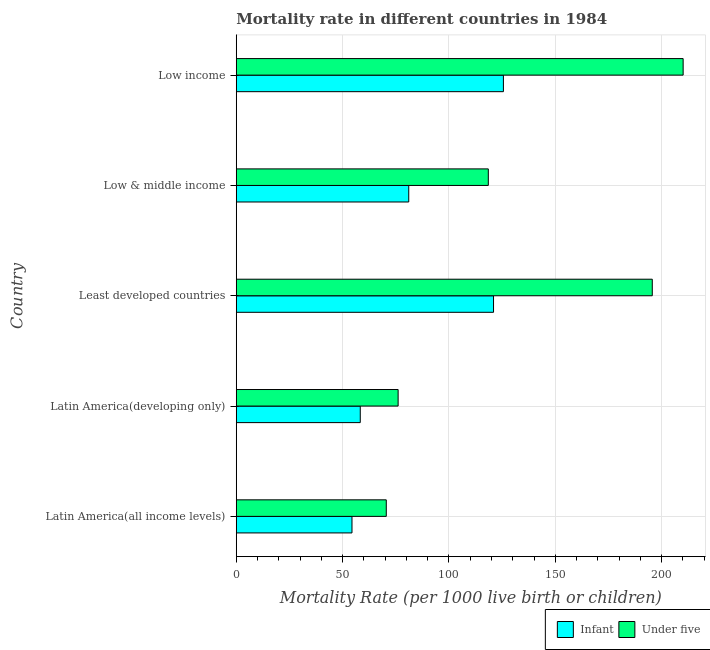How many groups of bars are there?
Give a very brief answer. 5. Are the number of bars on each tick of the Y-axis equal?
Your answer should be compact. Yes. What is the label of the 5th group of bars from the top?
Offer a very short reply. Latin America(all income levels). What is the under-5 mortality rate in Least developed countries?
Provide a succinct answer. 195.59. Across all countries, what is the maximum infant mortality rate?
Make the answer very short. 125.6. Across all countries, what is the minimum infant mortality rate?
Ensure brevity in your answer.  54.41. In which country was the infant mortality rate minimum?
Give a very brief answer. Latin America(all income levels). What is the total infant mortality rate in the graph?
Provide a short and direct response. 440.36. What is the difference between the under-5 mortality rate in Latin America(developing only) and that in Low & middle income?
Provide a succinct answer. -42.4. What is the difference between the infant mortality rate in Least developed countries and the under-5 mortality rate in Latin America(all income levels)?
Your answer should be very brief. 50.42. What is the average under-5 mortality rate per country?
Your answer should be very brief. 134.16. What is the difference between the infant mortality rate and under-5 mortality rate in Low income?
Make the answer very short. -84.5. In how many countries, is the under-5 mortality rate greater than 80 ?
Your answer should be very brief. 3. What is the difference between the highest and the second highest infant mortality rate?
Offer a terse response. 4.65. What is the difference between the highest and the lowest under-5 mortality rate?
Provide a succinct answer. 139.57. In how many countries, is the infant mortality rate greater than the average infant mortality rate taken over all countries?
Provide a short and direct response. 2. Is the sum of the infant mortality rate in Latin America(all income levels) and Least developed countries greater than the maximum under-5 mortality rate across all countries?
Give a very brief answer. No. What does the 2nd bar from the top in Latin America(all income levels) represents?
Provide a succinct answer. Infant. What does the 1st bar from the bottom in Low income represents?
Provide a succinct answer. Infant. How many bars are there?
Give a very brief answer. 10. How many countries are there in the graph?
Make the answer very short. 5. What is the difference between two consecutive major ticks on the X-axis?
Your response must be concise. 50. Are the values on the major ticks of X-axis written in scientific E-notation?
Your answer should be compact. No. Does the graph contain grids?
Provide a succinct answer. Yes. Where does the legend appear in the graph?
Give a very brief answer. Bottom right. How many legend labels are there?
Your response must be concise. 2. What is the title of the graph?
Offer a very short reply. Mortality rate in different countries in 1984. What is the label or title of the X-axis?
Your answer should be compact. Mortality Rate (per 1000 live birth or children). What is the label or title of the Y-axis?
Offer a terse response. Country. What is the Mortality Rate (per 1000 live birth or children) of Infant in Latin America(all income levels)?
Offer a very short reply. 54.41. What is the Mortality Rate (per 1000 live birth or children) in Under five in Latin America(all income levels)?
Give a very brief answer. 70.53. What is the Mortality Rate (per 1000 live birth or children) of Infant in Latin America(developing only)?
Give a very brief answer. 58.3. What is the Mortality Rate (per 1000 live birth or children) in Under five in Latin America(developing only)?
Keep it short and to the point. 76.1. What is the Mortality Rate (per 1000 live birth or children) of Infant in Least developed countries?
Keep it short and to the point. 120.95. What is the Mortality Rate (per 1000 live birth or children) of Under five in Least developed countries?
Make the answer very short. 195.59. What is the Mortality Rate (per 1000 live birth or children) in Infant in Low & middle income?
Your answer should be very brief. 81.1. What is the Mortality Rate (per 1000 live birth or children) of Under five in Low & middle income?
Make the answer very short. 118.5. What is the Mortality Rate (per 1000 live birth or children) in Infant in Low income?
Your answer should be compact. 125.6. What is the Mortality Rate (per 1000 live birth or children) in Under five in Low income?
Ensure brevity in your answer.  210.1. Across all countries, what is the maximum Mortality Rate (per 1000 live birth or children) in Infant?
Your response must be concise. 125.6. Across all countries, what is the maximum Mortality Rate (per 1000 live birth or children) in Under five?
Provide a short and direct response. 210.1. Across all countries, what is the minimum Mortality Rate (per 1000 live birth or children) of Infant?
Your answer should be compact. 54.41. Across all countries, what is the minimum Mortality Rate (per 1000 live birth or children) of Under five?
Ensure brevity in your answer.  70.53. What is the total Mortality Rate (per 1000 live birth or children) of Infant in the graph?
Offer a terse response. 440.36. What is the total Mortality Rate (per 1000 live birth or children) in Under five in the graph?
Your answer should be very brief. 670.82. What is the difference between the Mortality Rate (per 1000 live birth or children) of Infant in Latin America(all income levels) and that in Latin America(developing only)?
Make the answer very short. -3.89. What is the difference between the Mortality Rate (per 1000 live birth or children) of Under five in Latin America(all income levels) and that in Latin America(developing only)?
Your answer should be very brief. -5.57. What is the difference between the Mortality Rate (per 1000 live birth or children) of Infant in Latin America(all income levels) and that in Least developed countries?
Your answer should be very brief. -66.54. What is the difference between the Mortality Rate (per 1000 live birth or children) of Under five in Latin America(all income levels) and that in Least developed countries?
Make the answer very short. -125.06. What is the difference between the Mortality Rate (per 1000 live birth or children) of Infant in Latin America(all income levels) and that in Low & middle income?
Provide a short and direct response. -26.69. What is the difference between the Mortality Rate (per 1000 live birth or children) in Under five in Latin America(all income levels) and that in Low & middle income?
Keep it short and to the point. -47.97. What is the difference between the Mortality Rate (per 1000 live birth or children) in Infant in Latin America(all income levels) and that in Low income?
Provide a succinct answer. -71.19. What is the difference between the Mortality Rate (per 1000 live birth or children) of Under five in Latin America(all income levels) and that in Low income?
Your response must be concise. -139.57. What is the difference between the Mortality Rate (per 1000 live birth or children) of Infant in Latin America(developing only) and that in Least developed countries?
Give a very brief answer. -62.65. What is the difference between the Mortality Rate (per 1000 live birth or children) of Under five in Latin America(developing only) and that in Least developed countries?
Keep it short and to the point. -119.49. What is the difference between the Mortality Rate (per 1000 live birth or children) in Infant in Latin America(developing only) and that in Low & middle income?
Offer a very short reply. -22.8. What is the difference between the Mortality Rate (per 1000 live birth or children) in Under five in Latin America(developing only) and that in Low & middle income?
Provide a succinct answer. -42.4. What is the difference between the Mortality Rate (per 1000 live birth or children) of Infant in Latin America(developing only) and that in Low income?
Make the answer very short. -67.3. What is the difference between the Mortality Rate (per 1000 live birth or children) of Under five in Latin America(developing only) and that in Low income?
Ensure brevity in your answer.  -134. What is the difference between the Mortality Rate (per 1000 live birth or children) of Infant in Least developed countries and that in Low & middle income?
Your answer should be very brief. 39.85. What is the difference between the Mortality Rate (per 1000 live birth or children) in Under five in Least developed countries and that in Low & middle income?
Provide a short and direct response. 77.09. What is the difference between the Mortality Rate (per 1000 live birth or children) of Infant in Least developed countries and that in Low income?
Provide a succinct answer. -4.65. What is the difference between the Mortality Rate (per 1000 live birth or children) of Under five in Least developed countries and that in Low income?
Provide a short and direct response. -14.51. What is the difference between the Mortality Rate (per 1000 live birth or children) in Infant in Low & middle income and that in Low income?
Your answer should be compact. -44.5. What is the difference between the Mortality Rate (per 1000 live birth or children) of Under five in Low & middle income and that in Low income?
Your answer should be very brief. -91.6. What is the difference between the Mortality Rate (per 1000 live birth or children) of Infant in Latin America(all income levels) and the Mortality Rate (per 1000 live birth or children) of Under five in Latin America(developing only)?
Provide a succinct answer. -21.69. What is the difference between the Mortality Rate (per 1000 live birth or children) in Infant in Latin America(all income levels) and the Mortality Rate (per 1000 live birth or children) in Under five in Least developed countries?
Keep it short and to the point. -141.18. What is the difference between the Mortality Rate (per 1000 live birth or children) of Infant in Latin America(all income levels) and the Mortality Rate (per 1000 live birth or children) of Under five in Low & middle income?
Provide a succinct answer. -64.09. What is the difference between the Mortality Rate (per 1000 live birth or children) of Infant in Latin America(all income levels) and the Mortality Rate (per 1000 live birth or children) of Under five in Low income?
Your answer should be very brief. -155.69. What is the difference between the Mortality Rate (per 1000 live birth or children) of Infant in Latin America(developing only) and the Mortality Rate (per 1000 live birth or children) of Under five in Least developed countries?
Your answer should be very brief. -137.29. What is the difference between the Mortality Rate (per 1000 live birth or children) in Infant in Latin America(developing only) and the Mortality Rate (per 1000 live birth or children) in Under five in Low & middle income?
Offer a very short reply. -60.2. What is the difference between the Mortality Rate (per 1000 live birth or children) of Infant in Latin America(developing only) and the Mortality Rate (per 1000 live birth or children) of Under five in Low income?
Provide a succinct answer. -151.8. What is the difference between the Mortality Rate (per 1000 live birth or children) of Infant in Least developed countries and the Mortality Rate (per 1000 live birth or children) of Under five in Low & middle income?
Offer a terse response. 2.45. What is the difference between the Mortality Rate (per 1000 live birth or children) of Infant in Least developed countries and the Mortality Rate (per 1000 live birth or children) of Under five in Low income?
Ensure brevity in your answer.  -89.15. What is the difference between the Mortality Rate (per 1000 live birth or children) of Infant in Low & middle income and the Mortality Rate (per 1000 live birth or children) of Under five in Low income?
Offer a very short reply. -129. What is the average Mortality Rate (per 1000 live birth or children) in Infant per country?
Ensure brevity in your answer.  88.07. What is the average Mortality Rate (per 1000 live birth or children) in Under five per country?
Keep it short and to the point. 134.16. What is the difference between the Mortality Rate (per 1000 live birth or children) of Infant and Mortality Rate (per 1000 live birth or children) of Under five in Latin America(all income levels)?
Your answer should be compact. -16.12. What is the difference between the Mortality Rate (per 1000 live birth or children) in Infant and Mortality Rate (per 1000 live birth or children) in Under five in Latin America(developing only)?
Provide a short and direct response. -17.8. What is the difference between the Mortality Rate (per 1000 live birth or children) in Infant and Mortality Rate (per 1000 live birth or children) in Under five in Least developed countries?
Provide a short and direct response. -74.64. What is the difference between the Mortality Rate (per 1000 live birth or children) in Infant and Mortality Rate (per 1000 live birth or children) in Under five in Low & middle income?
Offer a terse response. -37.4. What is the difference between the Mortality Rate (per 1000 live birth or children) in Infant and Mortality Rate (per 1000 live birth or children) in Under five in Low income?
Provide a short and direct response. -84.5. What is the ratio of the Mortality Rate (per 1000 live birth or children) of Infant in Latin America(all income levels) to that in Latin America(developing only)?
Provide a succinct answer. 0.93. What is the ratio of the Mortality Rate (per 1000 live birth or children) of Under five in Latin America(all income levels) to that in Latin America(developing only)?
Your response must be concise. 0.93. What is the ratio of the Mortality Rate (per 1000 live birth or children) in Infant in Latin America(all income levels) to that in Least developed countries?
Make the answer very short. 0.45. What is the ratio of the Mortality Rate (per 1000 live birth or children) in Under five in Latin America(all income levels) to that in Least developed countries?
Provide a succinct answer. 0.36. What is the ratio of the Mortality Rate (per 1000 live birth or children) in Infant in Latin America(all income levels) to that in Low & middle income?
Offer a terse response. 0.67. What is the ratio of the Mortality Rate (per 1000 live birth or children) of Under five in Latin America(all income levels) to that in Low & middle income?
Make the answer very short. 0.6. What is the ratio of the Mortality Rate (per 1000 live birth or children) of Infant in Latin America(all income levels) to that in Low income?
Keep it short and to the point. 0.43. What is the ratio of the Mortality Rate (per 1000 live birth or children) of Under five in Latin America(all income levels) to that in Low income?
Give a very brief answer. 0.34. What is the ratio of the Mortality Rate (per 1000 live birth or children) in Infant in Latin America(developing only) to that in Least developed countries?
Your response must be concise. 0.48. What is the ratio of the Mortality Rate (per 1000 live birth or children) of Under five in Latin America(developing only) to that in Least developed countries?
Provide a succinct answer. 0.39. What is the ratio of the Mortality Rate (per 1000 live birth or children) of Infant in Latin America(developing only) to that in Low & middle income?
Your response must be concise. 0.72. What is the ratio of the Mortality Rate (per 1000 live birth or children) in Under five in Latin America(developing only) to that in Low & middle income?
Provide a succinct answer. 0.64. What is the ratio of the Mortality Rate (per 1000 live birth or children) in Infant in Latin America(developing only) to that in Low income?
Provide a succinct answer. 0.46. What is the ratio of the Mortality Rate (per 1000 live birth or children) of Under five in Latin America(developing only) to that in Low income?
Give a very brief answer. 0.36. What is the ratio of the Mortality Rate (per 1000 live birth or children) in Infant in Least developed countries to that in Low & middle income?
Your response must be concise. 1.49. What is the ratio of the Mortality Rate (per 1000 live birth or children) of Under five in Least developed countries to that in Low & middle income?
Your answer should be compact. 1.65. What is the ratio of the Mortality Rate (per 1000 live birth or children) in Under five in Least developed countries to that in Low income?
Offer a very short reply. 0.93. What is the ratio of the Mortality Rate (per 1000 live birth or children) in Infant in Low & middle income to that in Low income?
Keep it short and to the point. 0.65. What is the ratio of the Mortality Rate (per 1000 live birth or children) in Under five in Low & middle income to that in Low income?
Keep it short and to the point. 0.56. What is the difference between the highest and the second highest Mortality Rate (per 1000 live birth or children) in Infant?
Provide a short and direct response. 4.65. What is the difference between the highest and the second highest Mortality Rate (per 1000 live birth or children) of Under five?
Keep it short and to the point. 14.51. What is the difference between the highest and the lowest Mortality Rate (per 1000 live birth or children) in Infant?
Make the answer very short. 71.19. What is the difference between the highest and the lowest Mortality Rate (per 1000 live birth or children) in Under five?
Offer a terse response. 139.57. 